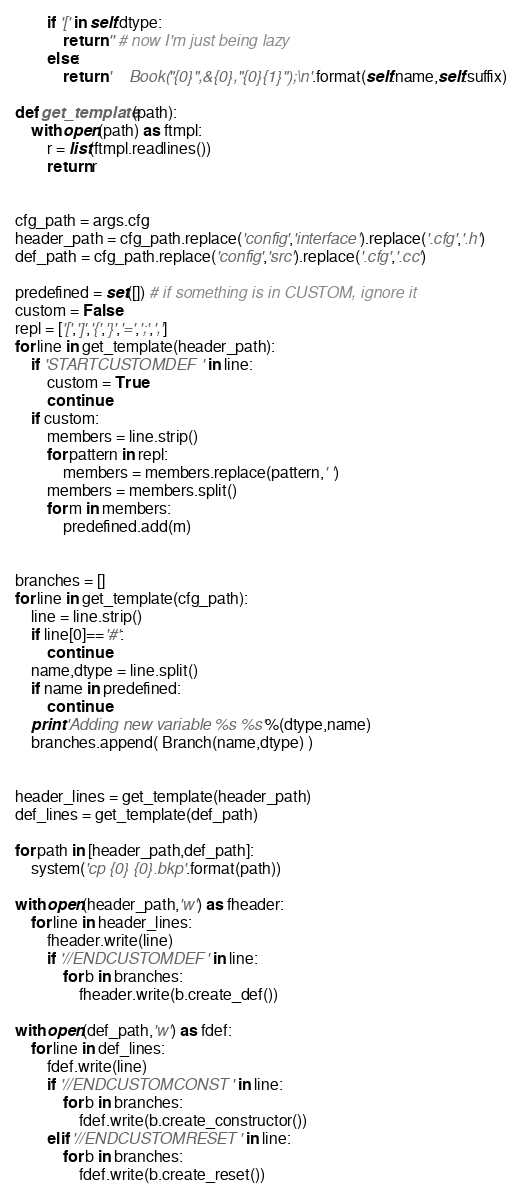Convert code to text. <code><loc_0><loc_0><loc_500><loc_500><_Python_>        if '[' in self.dtype:
            return '' # now I'm just being lazy
        else:
            return '    Book("{0}",&{0},"{0}{1}");\n'.format(self.name,self.suffix)

def get_template(path):
    with open(path) as ftmpl:
        r = list(ftmpl.readlines())
        return r


cfg_path = args.cfg
header_path = cfg_path.replace('config','interface').replace('.cfg','.h')
def_path = cfg_path.replace('config','src').replace('.cfg','.cc')

predefined = set([]) # if something is in CUSTOM, ignore it
custom = False
repl = ['[',']','{','}','=',';',',']
for line in get_template(header_path):
    if 'STARTCUSTOMDEF' in line:
        custom = True
        continue
    if custom:
        members = line.strip()
        for pattern in repl:
            members = members.replace(pattern,' ')
        members = members.split()
        for m in members:
            predefined.add(m)


branches = []
for line in get_template(cfg_path):
    line = line.strip()
    if line[0]=='#':
        continue
    name,dtype = line.split()
    if name in predefined:
        continue
    print 'Adding new variable %s %s'%(dtype,name)
    branches.append( Branch(name,dtype) )


header_lines = get_template(header_path)
def_lines = get_template(def_path)

for path in [header_path,def_path]:
    system('cp {0} {0}.bkp'.format(path))

with open(header_path,'w') as fheader:
    for line in header_lines:
        fheader.write(line)
        if '//ENDCUSTOMDEF' in line:
            for b in branches:
                fheader.write(b.create_def())

with open(def_path,'w') as fdef:
    for line in def_lines:
        fdef.write(line)
        if '//ENDCUSTOMCONST' in line:
            for b in branches:
                fdef.write(b.create_constructor())
        elif '//ENDCUSTOMRESET' in line:
            for b in branches:
                fdef.write(b.create_reset())</code> 